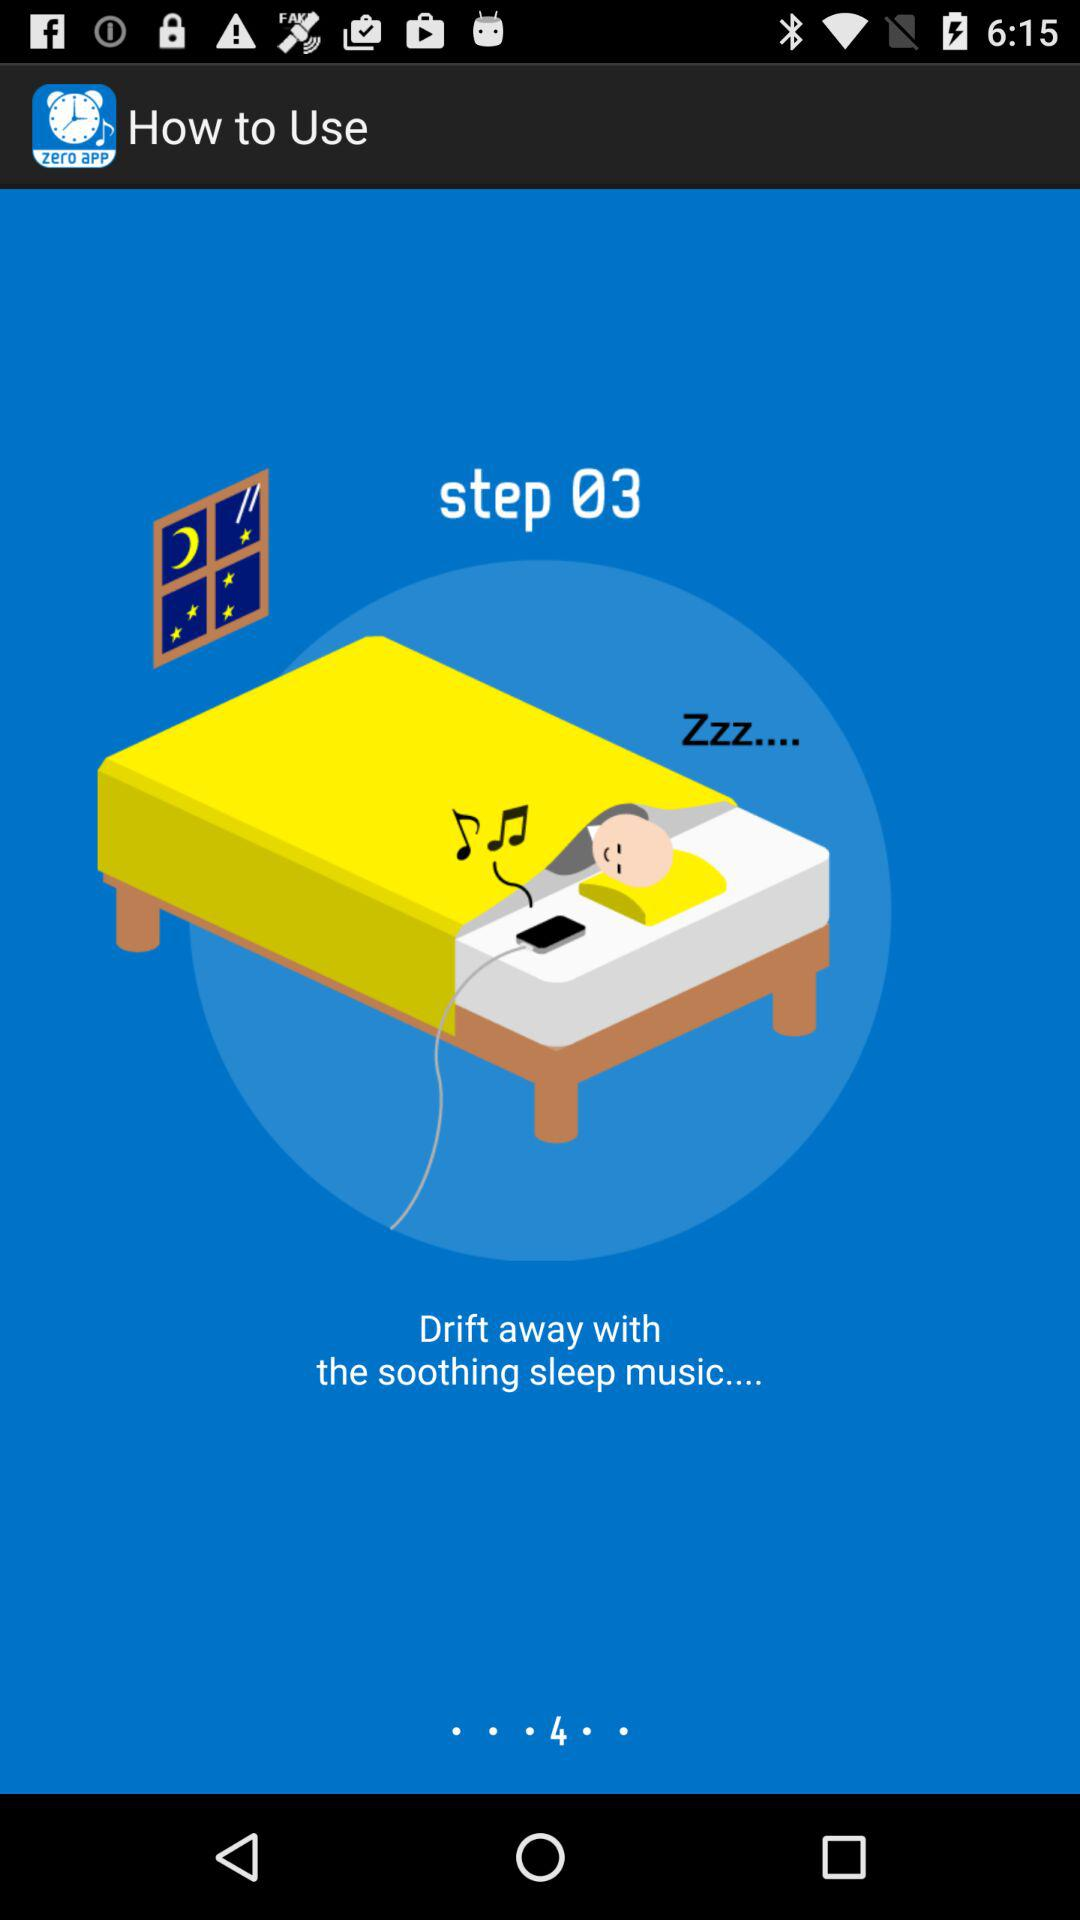On what step is the person? The person is on step 03. 